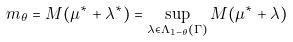Convert formula to latex. <formula><loc_0><loc_0><loc_500><loc_500>m _ { \theta } = M ( \mu ^ { * } + \lambda ^ { * } ) = \sup _ { \lambda \in \Lambda _ { 1 - \theta } ( \Gamma ) } M ( \mu ^ { * } + \lambda )</formula> 